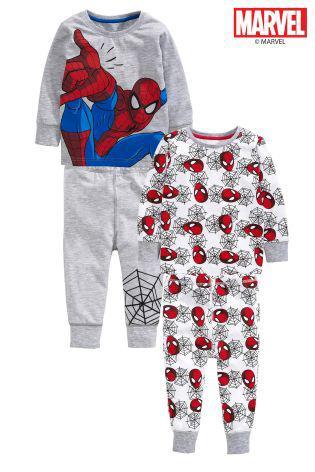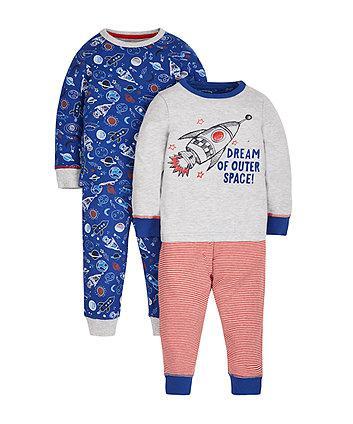The first image is the image on the left, the second image is the image on the right. For the images displayed, is the sentence "None of the pants have vertical or horizontal stripes." factually correct? Answer yes or no. Yes. The first image is the image on the left, the second image is the image on the right. Given the left and right images, does the statement "An image includes a short-sleeve top and a pair of striped pants." hold true? Answer yes or no. No. 